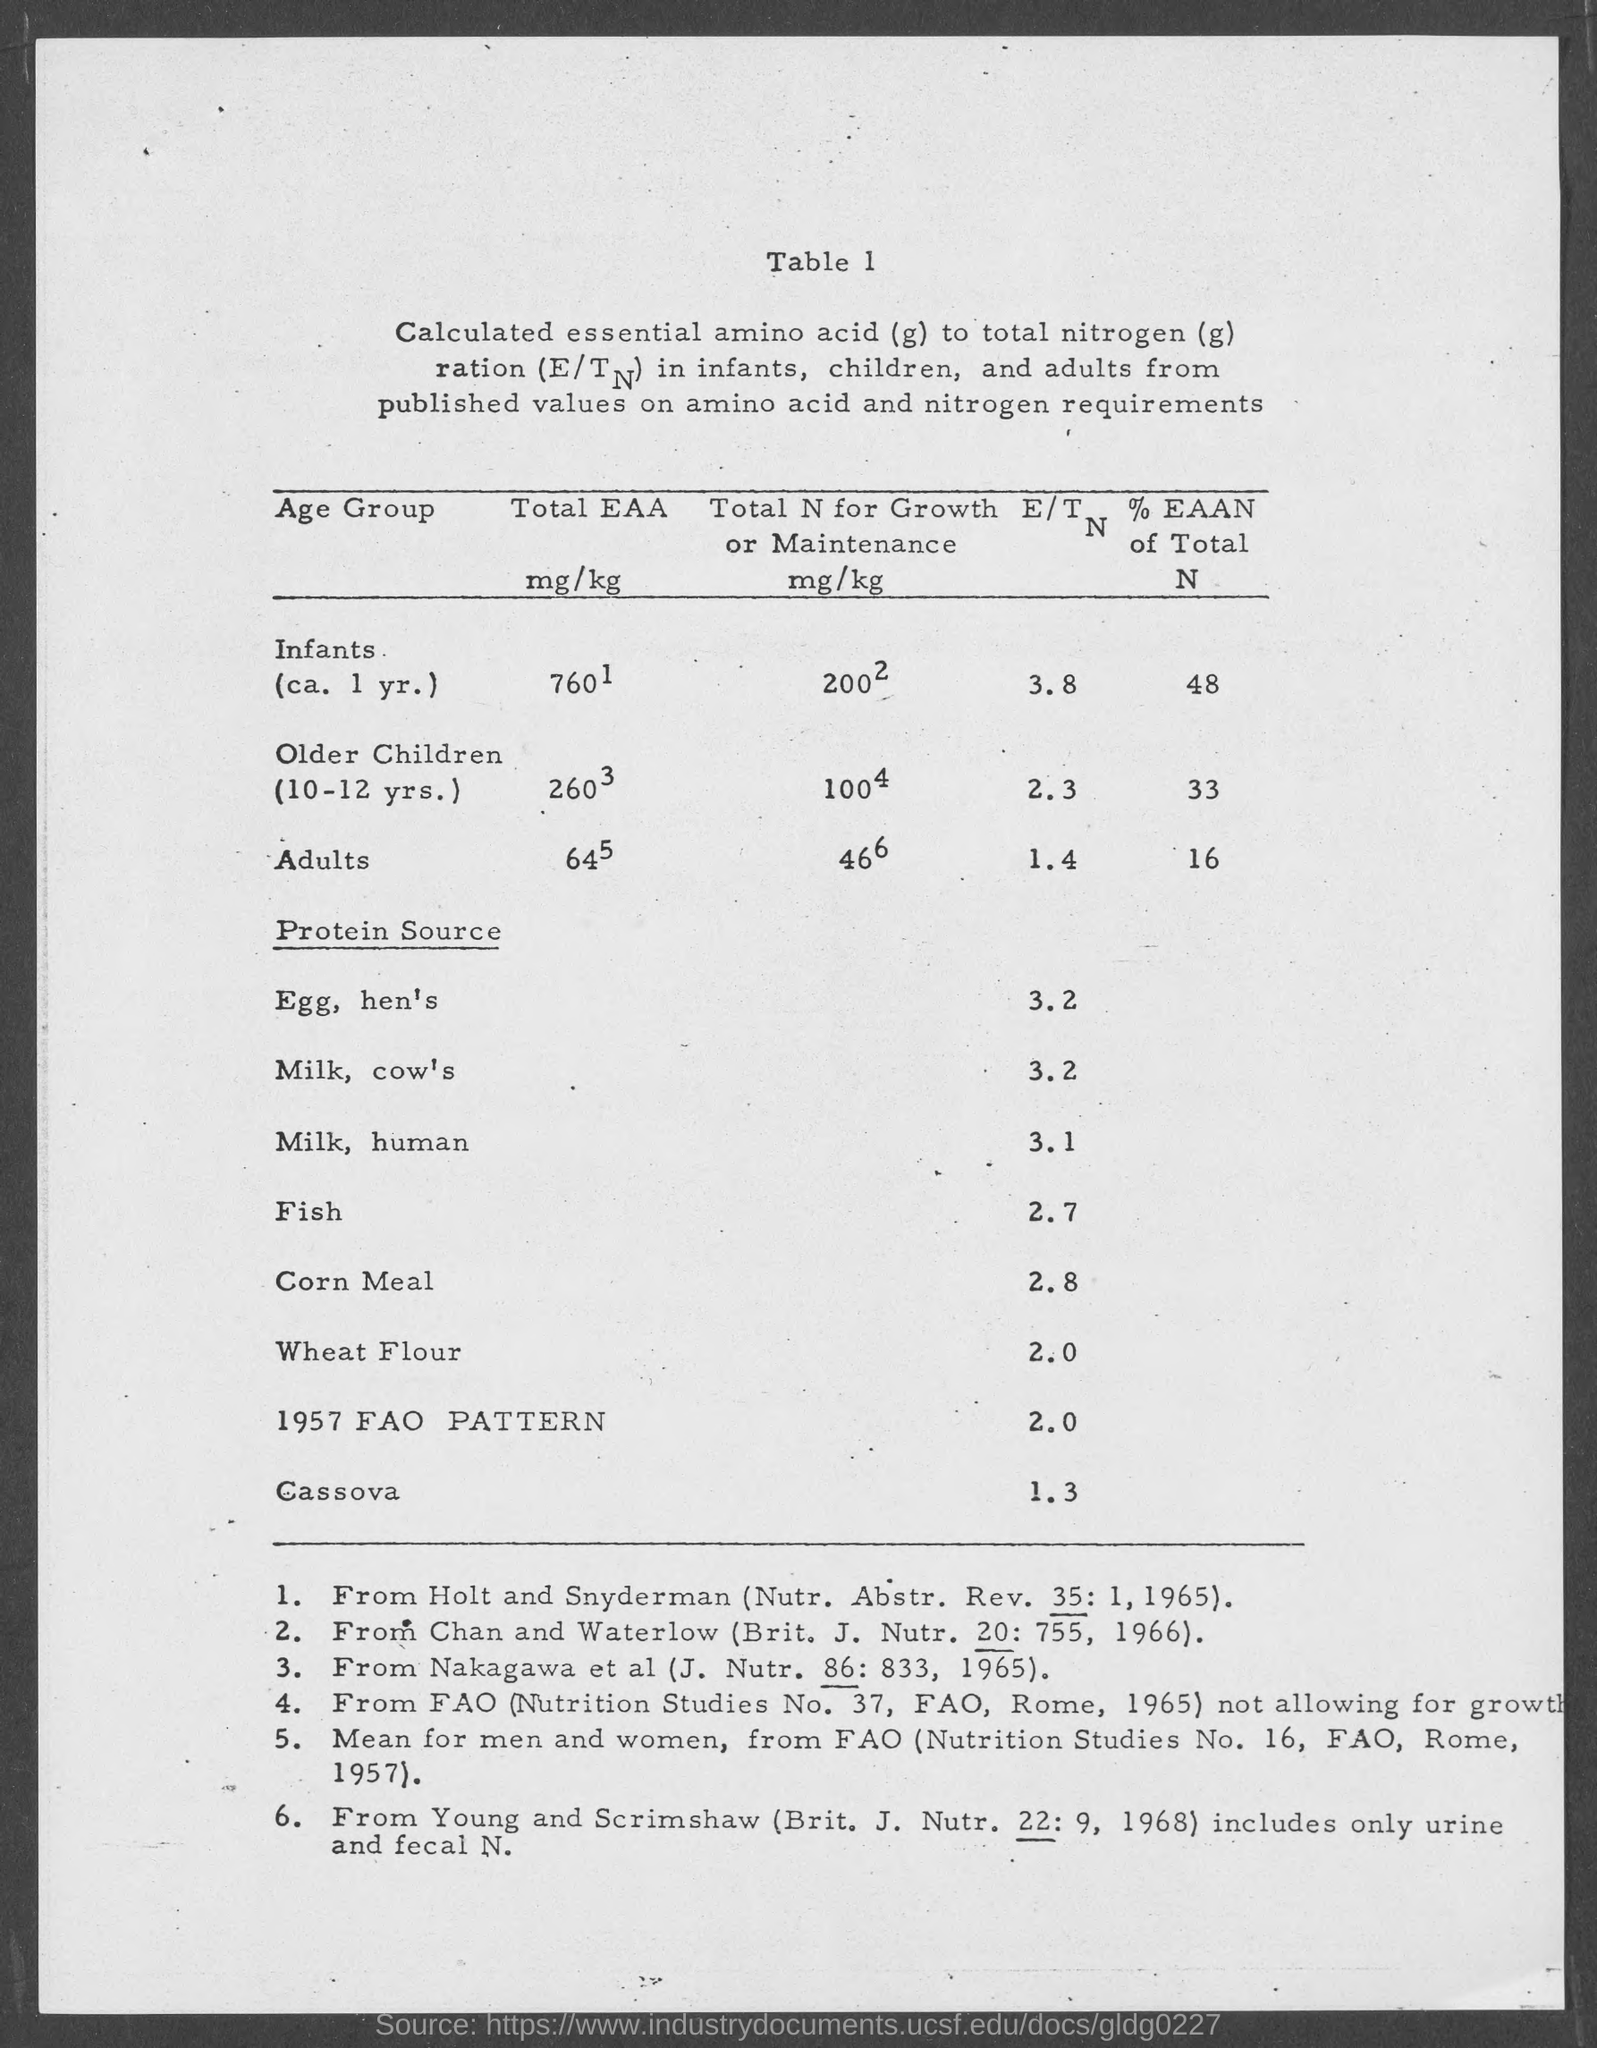What is the E/T for Infants (ca. 1 yr.)?
Your answer should be very brief. 3.8. What is the E/T for Older Children?
Make the answer very short. 2.3. What is the E/T for Adults?
Your answer should be compact. 1.4. What is the E/T for Egg, hen's?
Your response must be concise. 3.2. What is the E/T for milk, cow's?
Give a very brief answer. 3.2. What is the E/T for Milk, human?
Your answer should be very brief. 3.1. What is the E/T for Fish?
Make the answer very short. 2.7. What is the E/T for Corn meal?
Keep it short and to the point. 2.8. What is the E/T for Wheat Flour?
Your answer should be very brief. 2.0. What is the E/T for Cassova?
Ensure brevity in your answer.  1.3. 